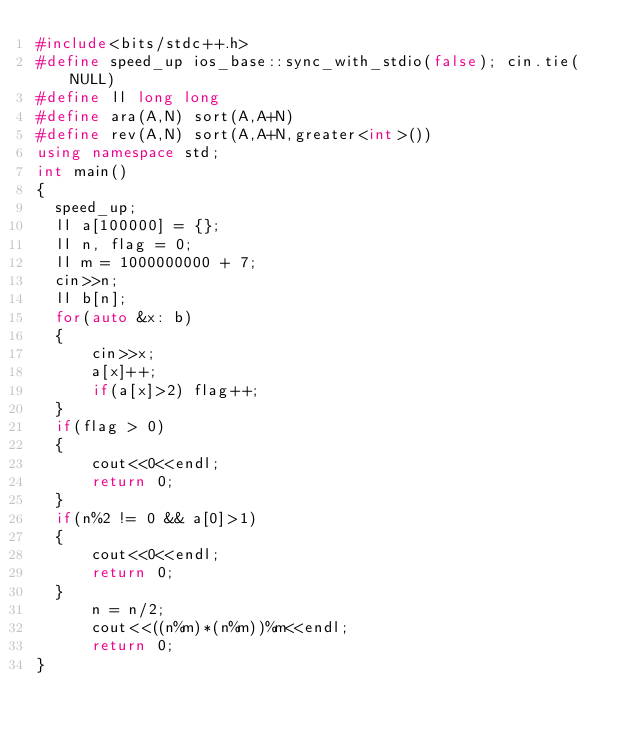<code> <loc_0><loc_0><loc_500><loc_500><_C++_>#include<bits/stdc++.h>
#define speed_up ios_base::sync_with_stdio(false); cin.tie(NULL)
#define ll long long
#define ara(A,N) sort(A,A+N)
#define rev(A,N) sort(A,A+N,greater<int>())
using namespace std;
int main()
{
  speed_up;
  ll a[100000] = {};
  ll n, flag = 0;
  ll m = 1000000000 + 7;
  cin>>n;
  ll b[n];
  for(auto &x: b)
  {
      cin>>x;
      a[x]++;
      if(a[x]>2) flag++;
  }
  if(flag > 0)
  {
      cout<<0<<endl;
      return 0;
  }
  if(n%2 != 0 && a[0]>1)
  {
      cout<<0<<endl;
      return 0;
  }
      n = n/2;
      cout<<((n%m)*(n%m))%m<<endl;
      return 0;
}
</code> 